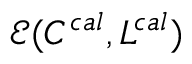<formula> <loc_0><loc_0><loc_500><loc_500>\mathcal { E } ( C ^ { c a l } , L ^ { c a l } )</formula> 